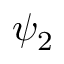Convert formula to latex. <formula><loc_0><loc_0><loc_500><loc_500>\psi _ { 2 }</formula> 